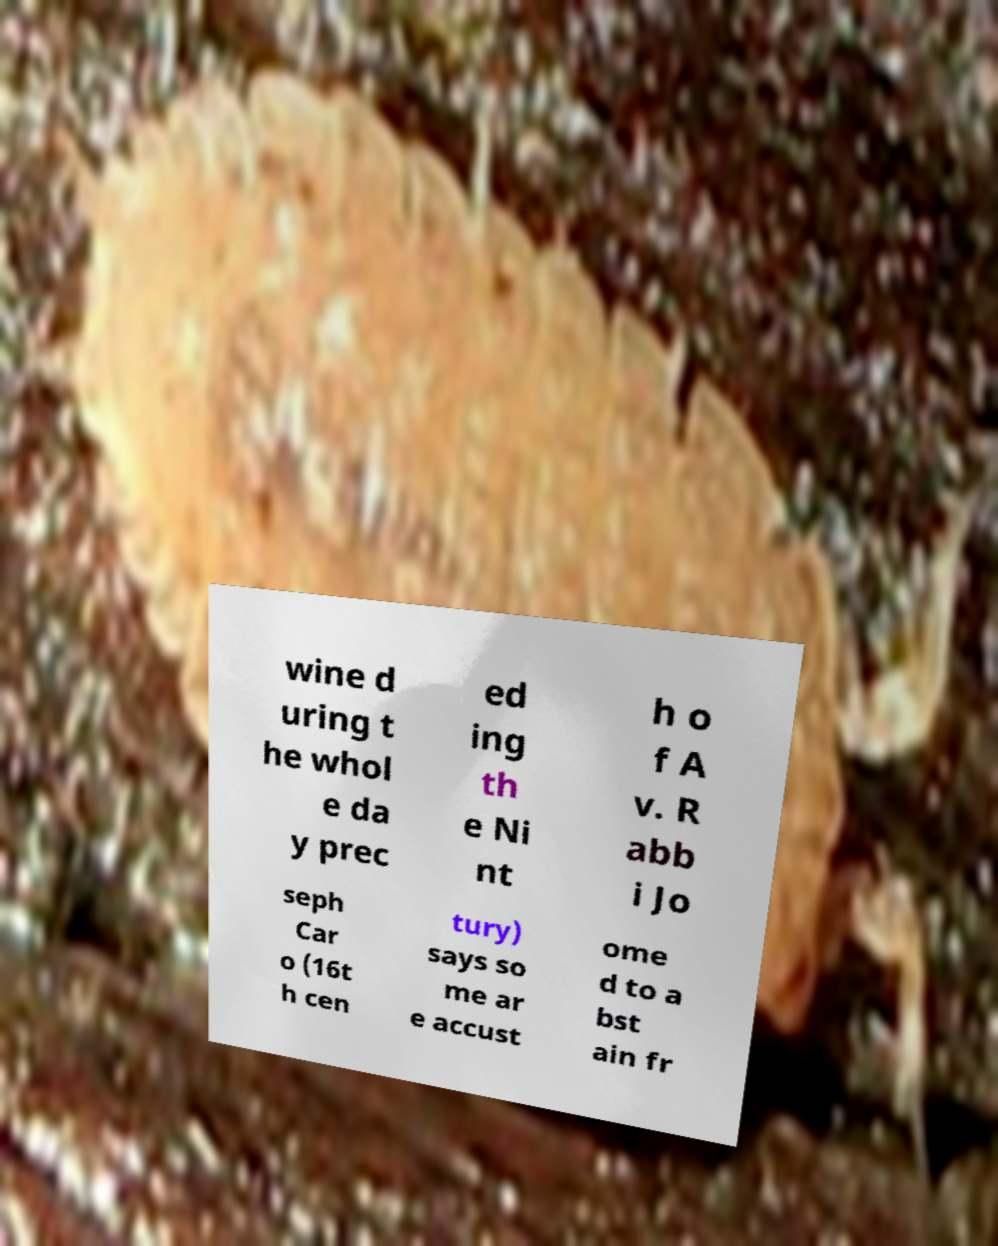What messages or text are displayed in this image? I need them in a readable, typed format. wine d uring t he whol e da y prec ed ing th e Ni nt h o f A v. R abb i Jo seph Car o (16t h cen tury) says so me ar e accust ome d to a bst ain fr 